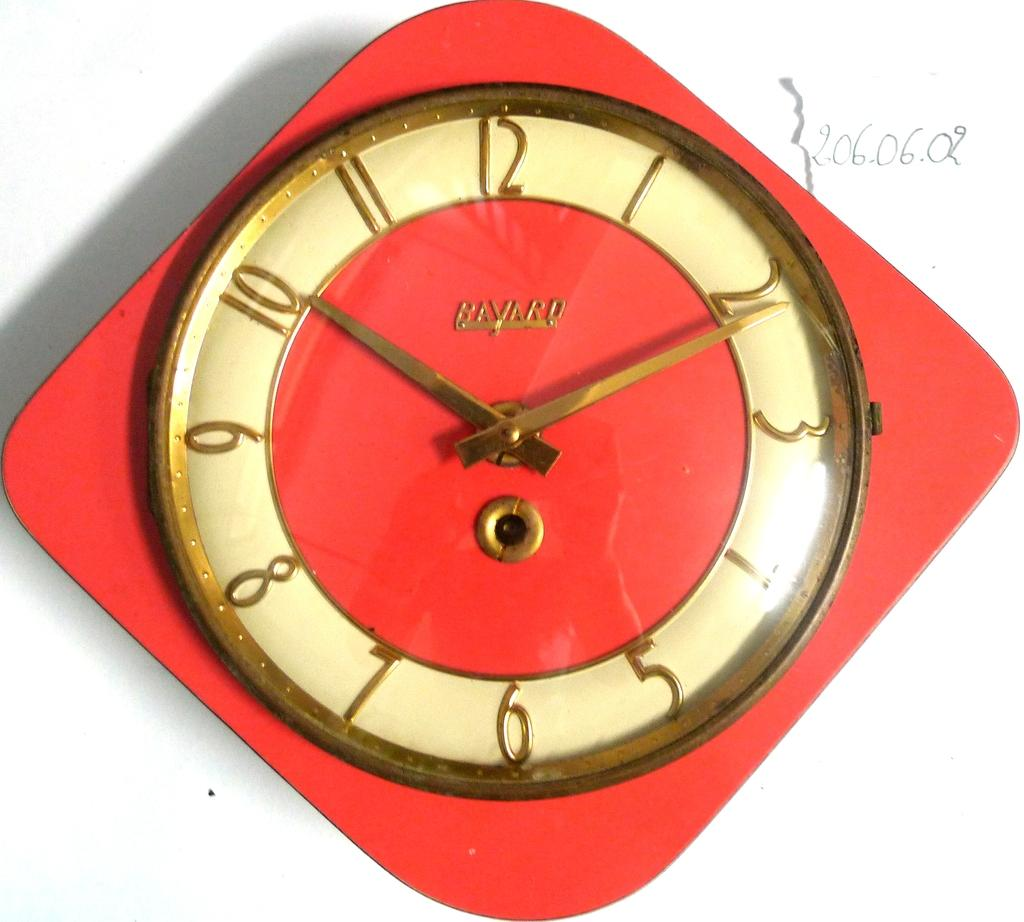<image>
Share a concise interpretation of the image provided. a BAVARD brand name old red wall clock with gold numbers, hands and trim. 